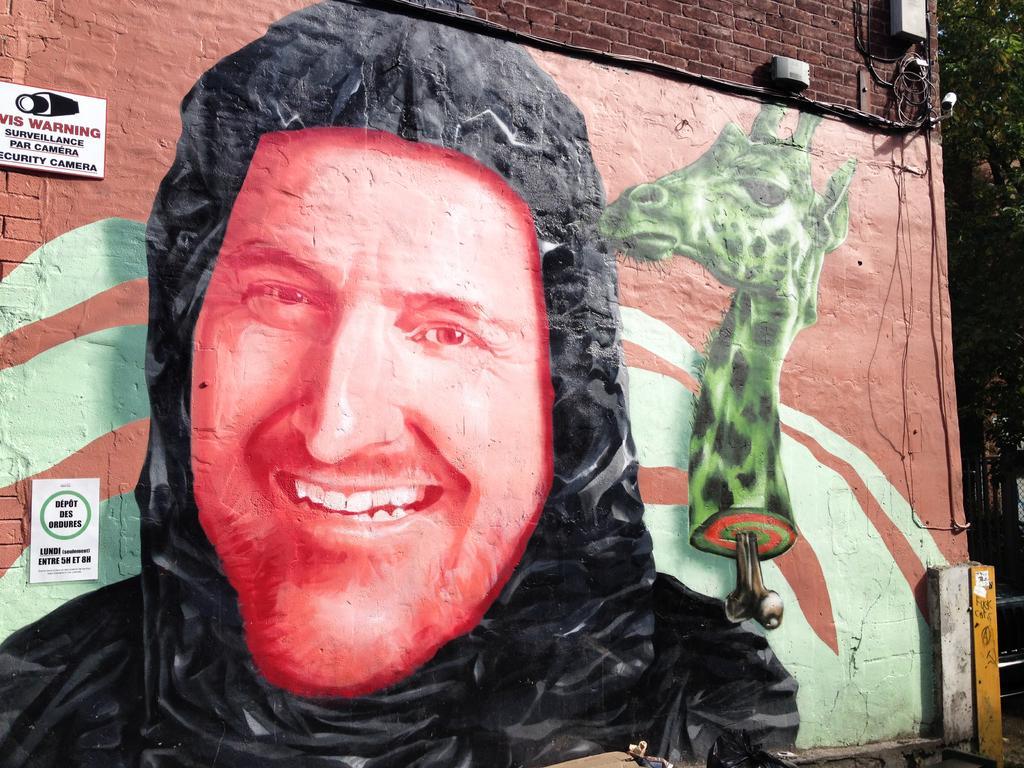Please provide a concise description of this image. In the image we can see there is a painting on the wall and the wall is made up of red bricks. There is a painting of a man wearing hoodie and there is a giraffe's head. There is a sign boards on the wall and behind there are trees. 